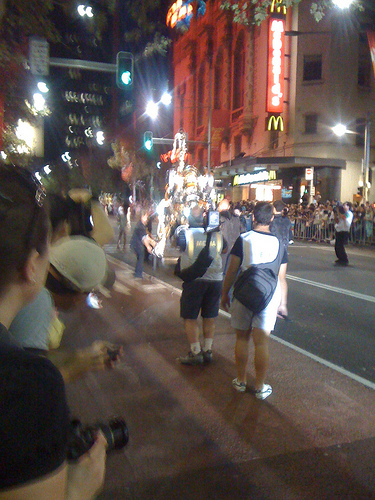<image>
Is the mcdonalds in the parade? No. The mcdonalds is not contained within the parade. These objects have a different spatial relationship. Is there a hat on the woman? No. The hat is not positioned on the woman. They may be near each other, but the hat is not supported by or resting on top of the woman. 